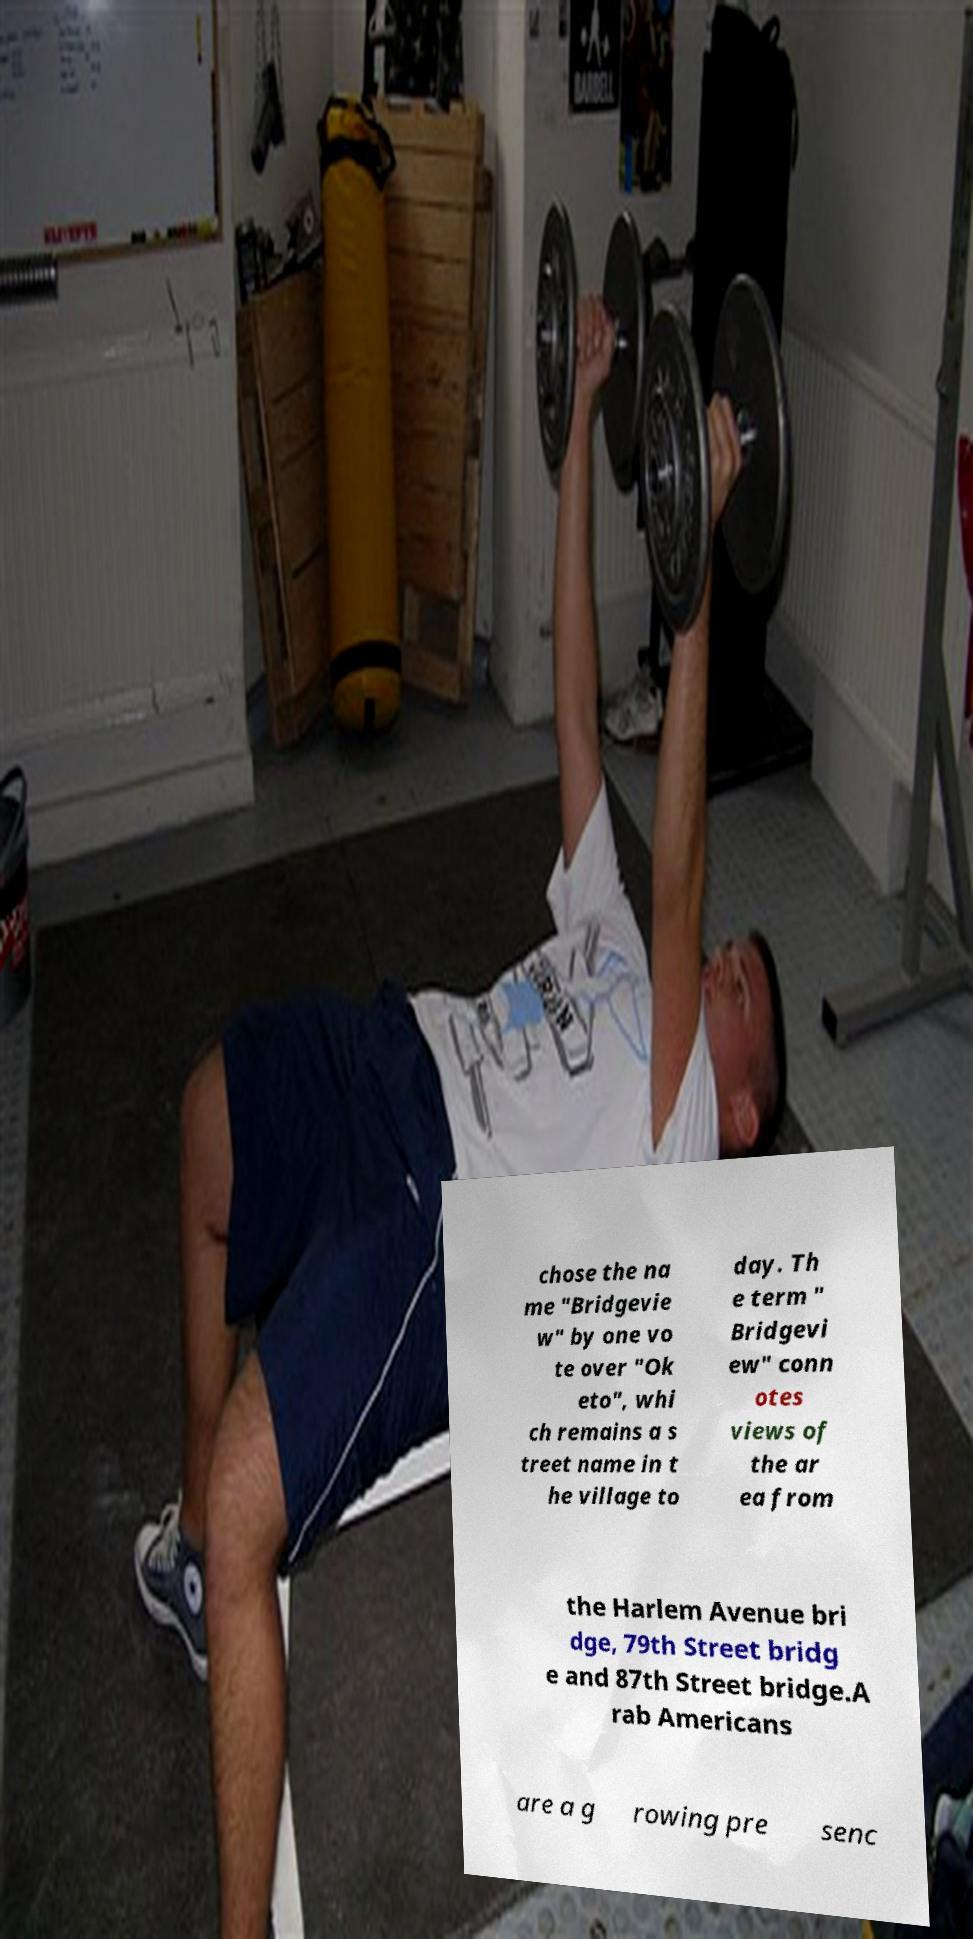Can you accurately transcribe the text from the provided image for me? chose the na me "Bridgevie w" by one vo te over "Ok eto", whi ch remains a s treet name in t he village to day. Th e term " Bridgevi ew" conn otes views of the ar ea from the Harlem Avenue bri dge, 79th Street bridg e and 87th Street bridge.A rab Americans are a g rowing pre senc 